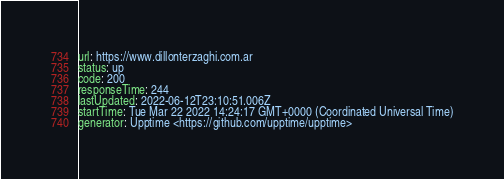Convert code to text. <code><loc_0><loc_0><loc_500><loc_500><_YAML_>url: https://www.dillonterzaghi.com.ar
status: up
code: 200
responseTime: 244
lastUpdated: 2022-06-12T23:10:51.006Z
startTime: Tue Mar 22 2022 14:24:17 GMT+0000 (Coordinated Universal Time)
generator: Upptime <https://github.com/upptime/upptime>
</code> 